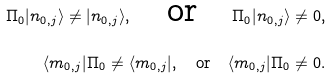Convert formula to latex. <formula><loc_0><loc_0><loc_500><loc_500>\Pi _ { 0 } | n _ { 0 , j } \rangle \neq | n _ { 0 , j } \rangle , \quad \text {or} \quad \Pi _ { 0 } | n _ { 0 , j } \rangle \neq 0 , \\ \langle m _ { 0 , j } | \Pi _ { 0 } \neq \langle m _ { 0 , j } | , \quad \text {or} \quad \langle m _ { 0 , j } | \Pi _ { 0 } \neq 0 .</formula> 